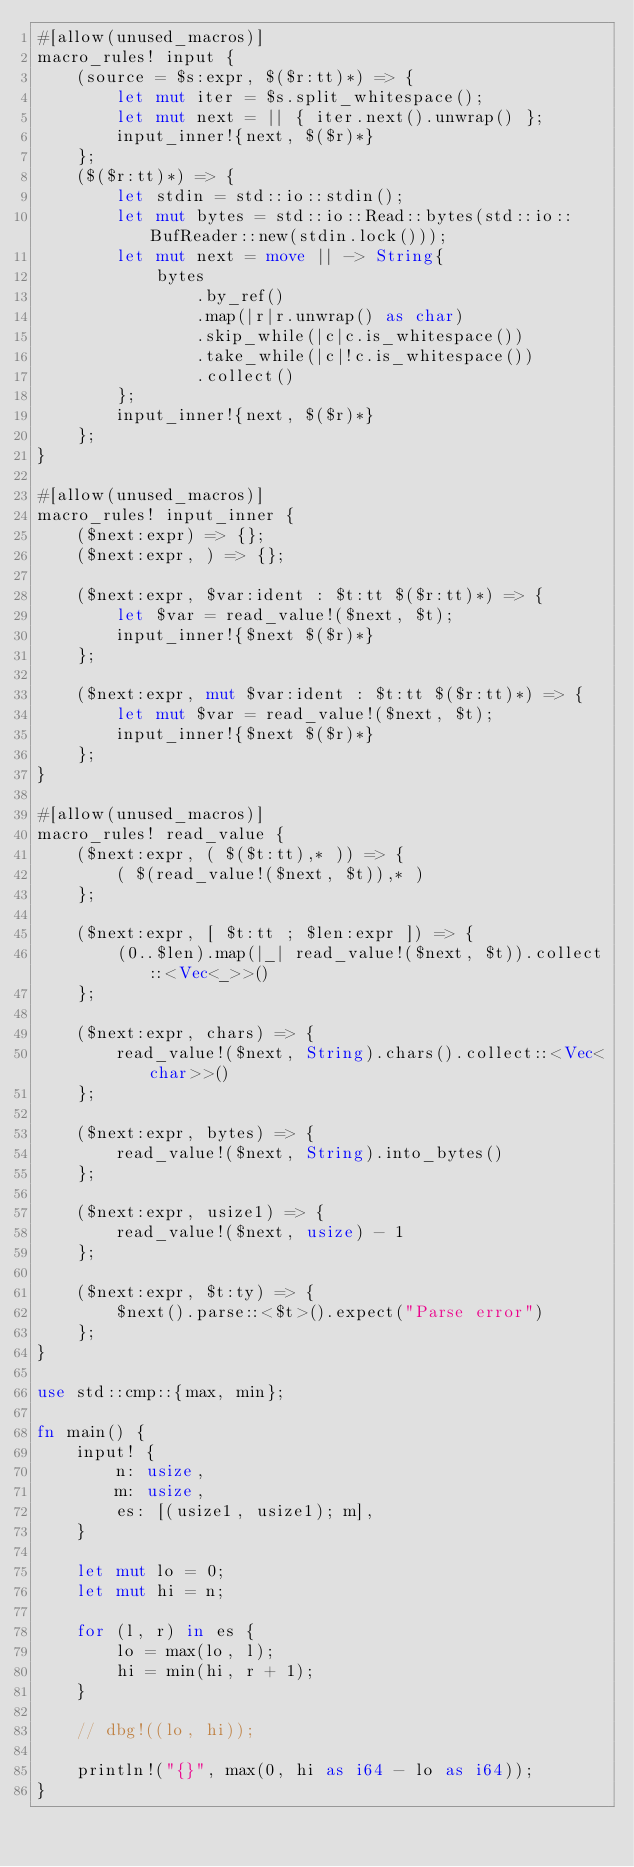Convert code to text. <code><loc_0><loc_0><loc_500><loc_500><_Rust_>#[allow(unused_macros)]
macro_rules! input {
    (source = $s:expr, $($r:tt)*) => {
        let mut iter = $s.split_whitespace();
        let mut next = || { iter.next().unwrap() };
        input_inner!{next, $($r)*}
    };
    ($($r:tt)*) => {
        let stdin = std::io::stdin();
        let mut bytes = std::io::Read::bytes(std::io::BufReader::new(stdin.lock()));
        let mut next = move || -> String{
            bytes
                .by_ref()
                .map(|r|r.unwrap() as char)
                .skip_while(|c|c.is_whitespace())
                .take_while(|c|!c.is_whitespace())
                .collect()
        };
        input_inner!{next, $($r)*}
    };
}

#[allow(unused_macros)]
macro_rules! input_inner {
    ($next:expr) => {};
    ($next:expr, ) => {};

    ($next:expr, $var:ident : $t:tt $($r:tt)*) => {
        let $var = read_value!($next, $t);
        input_inner!{$next $($r)*}
    };

    ($next:expr, mut $var:ident : $t:tt $($r:tt)*) => {
        let mut $var = read_value!($next, $t);
        input_inner!{$next $($r)*}
    };
}

#[allow(unused_macros)]
macro_rules! read_value {
    ($next:expr, ( $($t:tt),* )) => {
        ( $(read_value!($next, $t)),* )
    };

    ($next:expr, [ $t:tt ; $len:expr ]) => {
        (0..$len).map(|_| read_value!($next, $t)).collect::<Vec<_>>()
    };

    ($next:expr, chars) => {
        read_value!($next, String).chars().collect::<Vec<char>>()
    };

    ($next:expr, bytes) => {
        read_value!($next, String).into_bytes()
    };

    ($next:expr, usize1) => {
        read_value!($next, usize) - 1
    };

    ($next:expr, $t:ty) => {
        $next().parse::<$t>().expect("Parse error")
    };
}

use std::cmp::{max, min};

fn main() {
    input! {
        n: usize,
        m: usize,
        es: [(usize1, usize1); m],
    }

    let mut lo = 0;
    let mut hi = n;

    for (l, r) in es {
        lo = max(lo, l);
        hi = min(hi, r + 1);
    }

    // dbg!((lo, hi));

    println!("{}", max(0, hi as i64 - lo as i64));
}
</code> 